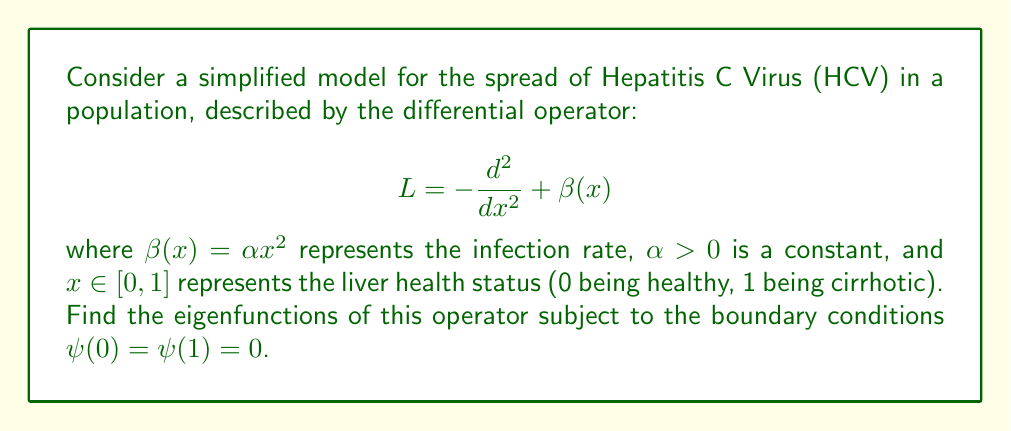Could you help me with this problem? To find the eigenfunctions, we need to solve the eigenvalue equation:

$$L\psi = \lambda\psi$$

Substituting the operator $L$, we get:

$$-\frac{d^2\psi}{dx^2} + \alpha x^2\psi = \lambda\psi$$

Rearranging:

$$\frac{d^2\psi}{dx^2} + (\lambda - \alpha x^2)\psi = 0$$

This is a form of the Weber differential equation. Its solutions are given by parabolic cylinder functions:

$$\psi(x) = c_1 D_{\nu}(\sqrt{2\alpha}x) + c_2 D_{-\nu-1}(i\sqrt{2\alpha}x)$$

where $\nu = -\frac{\lambda}{2\sqrt{\alpha}} - \frac{1}{2}$, and $D_{\nu}$ is the parabolic cylinder function.

Applying the boundary conditions:

1) $\psi(0) = 0$ implies $c_1 D_{\nu}(0) + c_2 D_{-\nu-1}(0) = 0$

2) $\psi(1) = 0$ implies $c_1 D_{\nu}(\sqrt{2\alpha}) + c_2 D_{-\nu-1}(i\sqrt{2\alpha}) = 0$

For non-trivial solutions, the determinant of this system must be zero:

$$D_{\nu}(0)D_{-\nu-1}(i\sqrt{2\alpha}) - D_{-\nu-1}(0)D_{\nu}(\sqrt{2\alpha}) = 0$$

This transcendental equation determines the eigenvalues $\lambda$. Each eigenvalue corresponds to an eigenfunction, which can be expressed as:

$$\psi_n(x) = D_{\nu_n}(\sqrt{2\alpha}x) - \frac{D_{\nu_n}(0)}{D_{-\nu_n-1}(0)}D_{-\nu_n-1}(i\sqrt{2\alpha}x)$$

where $\nu_n = -\frac{\lambda_n}{2\sqrt{\alpha}} - \frac{1}{2}$, and $\lambda_n$ are the solutions to the transcendental equation.
Answer: $\psi_n(x) = D_{\nu_n}(\sqrt{2\alpha}x) - \frac{D_{\nu_n}(0)}{D_{-\nu_n-1}(0)}D_{-\nu_n-1}(i\sqrt{2\alpha}x)$, where $\nu_n = -\frac{\lambda_n}{2\sqrt{\alpha}} - \frac{1}{2}$ 